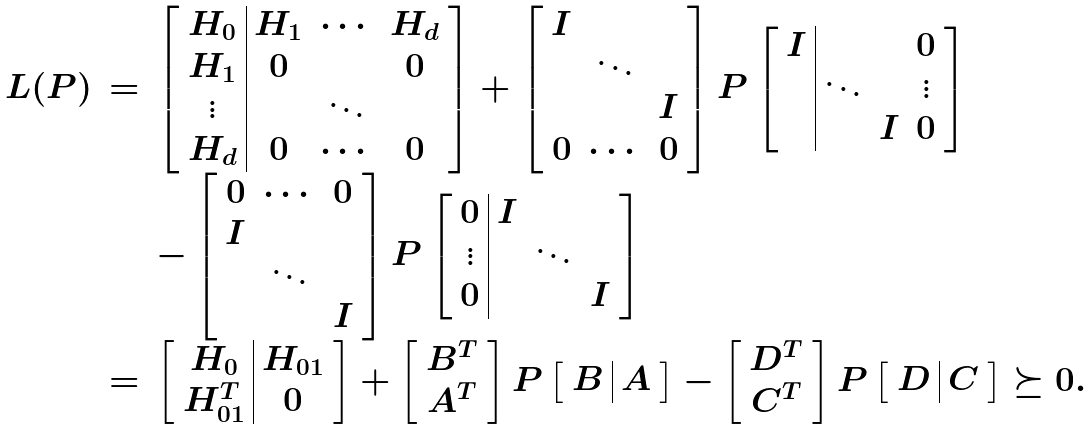Convert formula to latex. <formula><loc_0><loc_0><loc_500><loc_500>\begin{array} { r c l } L ( P ) & = & \left [ \begin{array} { c | c c c } H _ { 0 } & H _ { 1 } & \cdots & H _ { d } \\ H _ { 1 } & 0 & & 0 \\ \vdots & & \ddots \\ H _ { d } & 0 & \cdots & 0 \end{array} \right ] + \left [ \begin{array} { c c c } I \\ & \ddots \\ & & I \\ 0 & \cdots & 0 \end{array} \right ] P \left [ \begin{array} { c | c c c } I & & & 0 \\ & \ddots & & \vdots \\ & & I & 0 \end{array} \right ] \\ & & - \left [ \begin{array} { c c c } 0 & \cdots & 0 \\ I \\ & \ddots \\ & & I \\ \end{array} \right ] P \left [ \begin{array} { c | c c c } 0 & I \\ \vdots & & \ddots \\ 0 & & & I \end{array} \right ] \\ & = & \left [ \begin{array} { c | c } H _ { 0 } & H _ { 0 1 } \\ H _ { 0 1 } ^ { T } & 0 \end{array} \right ] + \left [ \begin{array} { c } B ^ { T } \\ A ^ { T } \end{array} \right ] P \left [ \begin{array} { c | c } B & A \end{array} \right ] - \left [ \begin{array} { c } D ^ { T } \\ C ^ { T } \end{array} \right ] P \left [ \begin{array} { c | c } D & C \end{array} \right ] \succeq 0 . \end{array}</formula> 